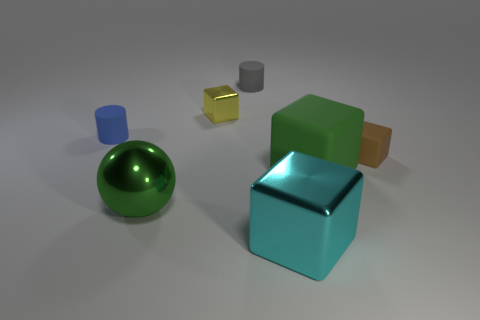Is there a large thing that has the same color as the large matte block?
Make the answer very short. Yes. There is a large block in front of the green thing that is on the left side of the large green cube; what color is it?
Provide a short and direct response. Cyan. There is a metal block that is in front of the rubber cylinder that is on the left side of the tiny cube left of the tiny brown block; what size is it?
Provide a succinct answer. Large. Do the brown block and the small block that is left of the cyan metal block have the same material?
Ensure brevity in your answer.  No. What is the size of the cylinder that is the same material as the tiny blue object?
Make the answer very short. Small. Is there a red object that has the same shape as the small blue rubber object?
Your answer should be compact. No. What number of objects are matte cubes behind the big green block or metal balls?
Provide a short and direct response. 2. There is a shiny object that is the same color as the big matte cube; what size is it?
Keep it short and to the point. Large. There is a big object that is behind the large green ball; does it have the same color as the big thing to the left of the small yellow object?
Provide a short and direct response. Yes. The green matte object is what size?
Ensure brevity in your answer.  Large. 